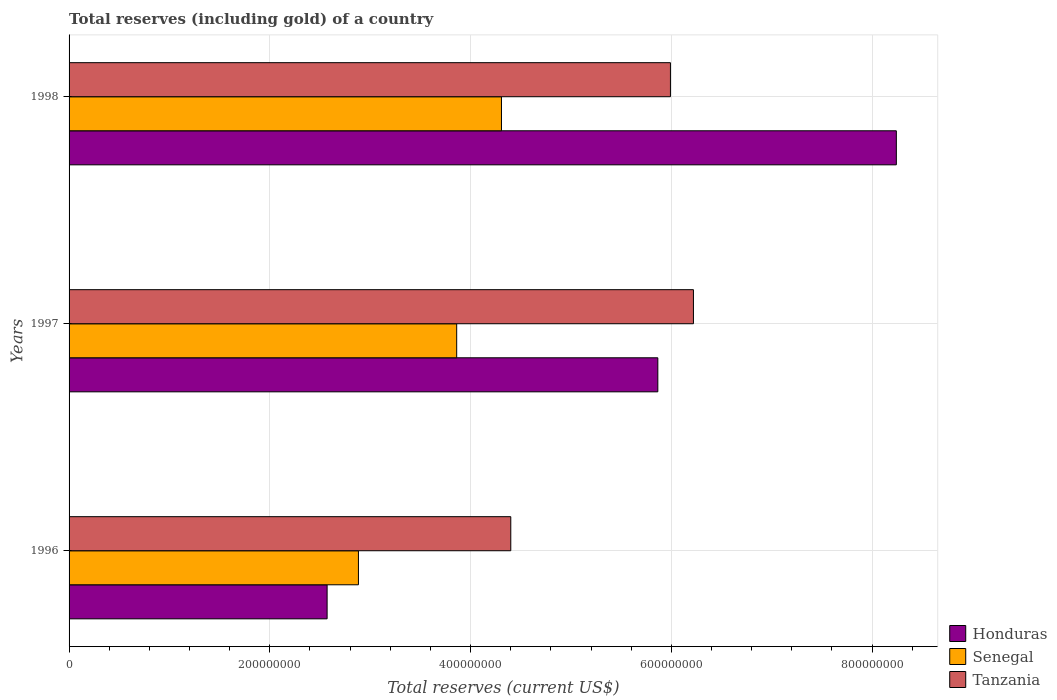How many bars are there on the 2nd tick from the top?
Give a very brief answer. 3. What is the label of the 2nd group of bars from the top?
Offer a very short reply. 1997. What is the total reserves (including gold) in Senegal in 1997?
Ensure brevity in your answer.  3.86e+08. Across all years, what is the maximum total reserves (including gold) in Honduras?
Your answer should be compact. 8.24e+08. Across all years, what is the minimum total reserves (including gold) in Tanzania?
Your answer should be very brief. 4.40e+08. In which year was the total reserves (including gold) in Senegal maximum?
Ensure brevity in your answer.  1998. What is the total total reserves (including gold) in Tanzania in the graph?
Provide a succinct answer. 1.66e+09. What is the difference between the total reserves (including gold) in Honduras in 1997 and that in 1998?
Provide a short and direct response. -2.38e+08. What is the difference between the total reserves (including gold) in Tanzania in 1996 and the total reserves (including gold) in Senegal in 1997?
Keep it short and to the point. 5.39e+07. What is the average total reserves (including gold) in Tanzania per year?
Your answer should be very brief. 5.54e+08. In the year 1997, what is the difference between the total reserves (including gold) in Honduras and total reserves (including gold) in Tanzania?
Make the answer very short. -3.55e+07. What is the ratio of the total reserves (including gold) in Honduras in 1996 to that in 1998?
Offer a very short reply. 0.31. Is the total reserves (including gold) in Honduras in 1996 less than that in 1998?
Give a very brief answer. Yes. Is the difference between the total reserves (including gold) in Honduras in 1996 and 1997 greater than the difference between the total reserves (including gold) in Tanzania in 1996 and 1997?
Offer a terse response. No. What is the difference between the highest and the second highest total reserves (including gold) in Honduras?
Give a very brief answer. 2.38e+08. What is the difference between the highest and the lowest total reserves (including gold) in Senegal?
Make the answer very short. 1.43e+08. Is the sum of the total reserves (including gold) in Honduras in 1997 and 1998 greater than the maximum total reserves (including gold) in Senegal across all years?
Offer a very short reply. Yes. What does the 3rd bar from the top in 1996 represents?
Your response must be concise. Honduras. What does the 2nd bar from the bottom in 1997 represents?
Make the answer very short. Senegal. Are all the bars in the graph horizontal?
Give a very brief answer. Yes. Are the values on the major ticks of X-axis written in scientific E-notation?
Make the answer very short. No. How are the legend labels stacked?
Your answer should be very brief. Vertical. What is the title of the graph?
Provide a succinct answer. Total reserves (including gold) of a country. What is the label or title of the X-axis?
Your response must be concise. Total reserves (current US$). What is the label or title of the Y-axis?
Give a very brief answer. Years. What is the Total reserves (current US$) of Honduras in 1996?
Offer a terse response. 2.57e+08. What is the Total reserves (current US$) of Senegal in 1996?
Provide a short and direct response. 2.88e+08. What is the Total reserves (current US$) in Tanzania in 1996?
Give a very brief answer. 4.40e+08. What is the Total reserves (current US$) in Honduras in 1997?
Provide a succinct answer. 5.87e+08. What is the Total reserves (current US$) in Senegal in 1997?
Keep it short and to the point. 3.86e+08. What is the Total reserves (current US$) of Tanzania in 1997?
Keep it short and to the point. 6.22e+08. What is the Total reserves (current US$) in Honduras in 1998?
Your answer should be compact. 8.24e+08. What is the Total reserves (current US$) of Senegal in 1998?
Offer a very short reply. 4.31e+08. What is the Total reserves (current US$) in Tanzania in 1998?
Provide a short and direct response. 5.99e+08. Across all years, what is the maximum Total reserves (current US$) of Honduras?
Your response must be concise. 8.24e+08. Across all years, what is the maximum Total reserves (current US$) in Senegal?
Your response must be concise. 4.31e+08. Across all years, what is the maximum Total reserves (current US$) of Tanzania?
Give a very brief answer. 6.22e+08. Across all years, what is the minimum Total reserves (current US$) of Honduras?
Ensure brevity in your answer.  2.57e+08. Across all years, what is the minimum Total reserves (current US$) of Senegal?
Provide a succinct answer. 2.88e+08. Across all years, what is the minimum Total reserves (current US$) in Tanzania?
Offer a very short reply. 4.40e+08. What is the total Total reserves (current US$) in Honduras in the graph?
Your answer should be very brief. 1.67e+09. What is the total Total reserves (current US$) in Senegal in the graph?
Ensure brevity in your answer.  1.11e+09. What is the total Total reserves (current US$) in Tanzania in the graph?
Give a very brief answer. 1.66e+09. What is the difference between the Total reserves (current US$) in Honduras in 1996 and that in 1997?
Your response must be concise. -3.29e+08. What is the difference between the Total reserves (current US$) of Senegal in 1996 and that in 1997?
Offer a terse response. -9.79e+07. What is the difference between the Total reserves (current US$) in Tanzania in 1996 and that in 1997?
Make the answer very short. -1.82e+08. What is the difference between the Total reserves (current US$) in Honduras in 1996 and that in 1998?
Provide a succinct answer. -5.67e+08. What is the difference between the Total reserves (current US$) of Senegal in 1996 and that in 1998?
Provide a succinct answer. -1.43e+08. What is the difference between the Total reserves (current US$) of Tanzania in 1996 and that in 1998?
Your answer should be compact. -1.59e+08. What is the difference between the Total reserves (current US$) of Honduras in 1997 and that in 1998?
Offer a terse response. -2.38e+08. What is the difference between the Total reserves (current US$) in Senegal in 1997 and that in 1998?
Give a very brief answer. -4.46e+07. What is the difference between the Total reserves (current US$) of Tanzania in 1997 and that in 1998?
Give a very brief answer. 2.29e+07. What is the difference between the Total reserves (current US$) of Honduras in 1996 and the Total reserves (current US$) of Senegal in 1997?
Make the answer very short. -1.29e+08. What is the difference between the Total reserves (current US$) of Honduras in 1996 and the Total reserves (current US$) of Tanzania in 1997?
Make the answer very short. -3.65e+08. What is the difference between the Total reserves (current US$) of Senegal in 1996 and the Total reserves (current US$) of Tanzania in 1997?
Ensure brevity in your answer.  -3.34e+08. What is the difference between the Total reserves (current US$) of Honduras in 1996 and the Total reserves (current US$) of Senegal in 1998?
Provide a succinct answer. -1.74e+08. What is the difference between the Total reserves (current US$) of Honduras in 1996 and the Total reserves (current US$) of Tanzania in 1998?
Offer a very short reply. -3.42e+08. What is the difference between the Total reserves (current US$) in Senegal in 1996 and the Total reserves (current US$) in Tanzania in 1998?
Keep it short and to the point. -3.11e+08. What is the difference between the Total reserves (current US$) of Honduras in 1997 and the Total reserves (current US$) of Senegal in 1998?
Keep it short and to the point. 1.56e+08. What is the difference between the Total reserves (current US$) in Honduras in 1997 and the Total reserves (current US$) in Tanzania in 1998?
Offer a very short reply. -1.26e+07. What is the difference between the Total reserves (current US$) in Senegal in 1997 and the Total reserves (current US$) in Tanzania in 1998?
Your response must be concise. -2.13e+08. What is the average Total reserves (current US$) in Honduras per year?
Ensure brevity in your answer.  5.56e+08. What is the average Total reserves (current US$) in Senegal per year?
Offer a terse response. 3.68e+08. What is the average Total reserves (current US$) of Tanzania per year?
Ensure brevity in your answer.  5.54e+08. In the year 1996, what is the difference between the Total reserves (current US$) of Honduras and Total reserves (current US$) of Senegal?
Offer a terse response. -3.12e+07. In the year 1996, what is the difference between the Total reserves (current US$) of Honduras and Total reserves (current US$) of Tanzania?
Your answer should be compact. -1.83e+08. In the year 1996, what is the difference between the Total reserves (current US$) of Senegal and Total reserves (current US$) of Tanzania?
Offer a very short reply. -1.52e+08. In the year 1997, what is the difference between the Total reserves (current US$) in Honduras and Total reserves (current US$) in Senegal?
Give a very brief answer. 2.00e+08. In the year 1997, what is the difference between the Total reserves (current US$) in Honduras and Total reserves (current US$) in Tanzania?
Make the answer very short. -3.55e+07. In the year 1997, what is the difference between the Total reserves (current US$) in Senegal and Total reserves (current US$) in Tanzania?
Your answer should be compact. -2.36e+08. In the year 1998, what is the difference between the Total reserves (current US$) in Honduras and Total reserves (current US$) in Senegal?
Provide a succinct answer. 3.93e+08. In the year 1998, what is the difference between the Total reserves (current US$) in Honduras and Total reserves (current US$) in Tanzania?
Offer a very short reply. 2.25e+08. In the year 1998, what is the difference between the Total reserves (current US$) of Senegal and Total reserves (current US$) of Tanzania?
Your answer should be compact. -1.68e+08. What is the ratio of the Total reserves (current US$) of Honduras in 1996 to that in 1997?
Your answer should be compact. 0.44. What is the ratio of the Total reserves (current US$) in Senegal in 1996 to that in 1997?
Keep it short and to the point. 0.75. What is the ratio of the Total reserves (current US$) in Tanzania in 1996 to that in 1997?
Your response must be concise. 0.71. What is the ratio of the Total reserves (current US$) in Honduras in 1996 to that in 1998?
Your response must be concise. 0.31. What is the ratio of the Total reserves (current US$) in Senegal in 1996 to that in 1998?
Keep it short and to the point. 0.67. What is the ratio of the Total reserves (current US$) of Tanzania in 1996 to that in 1998?
Provide a short and direct response. 0.73. What is the ratio of the Total reserves (current US$) of Honduras in 1997 to that in 1998?
Keep it short and to the point. 0.71. What is the ratio of the Total reserves (current US$) in Senegal in 1997 to that in 1998?
Your answer should be compact. 0.9. What is the ratio of the Total reserves (current US$) in Tanzania in 1997 to that in 1998?
Your answer should be very brief. 1.04. What is the difference between the highest and the second highest Total reserves (current US$) in Honduras?
Make the answer very short. 2.38e+08. What is the difference between the highest and the second highest Total reserves (current US$) of Senegal?
Your response must be concise. 4.46e+07. What is the difference between the highest and the second highest Total reserves (current US$) of Tanzania?
Ensure brevity in your answer.  2.29e+07. What is the difference between the highest and the lowest Total reserves (current US$) in Honduras?
Keep it short and to the point. 5.67e+08. What is the difference between the highest and the lowest Total reserves (current US$) in Senegal?
Provide a short and direct response. 1.43e+08. What is the difference between the highest and the lowest Total reserves (current US$) of Tanzania?
Your answer should be very brief. 1.82e+08. 